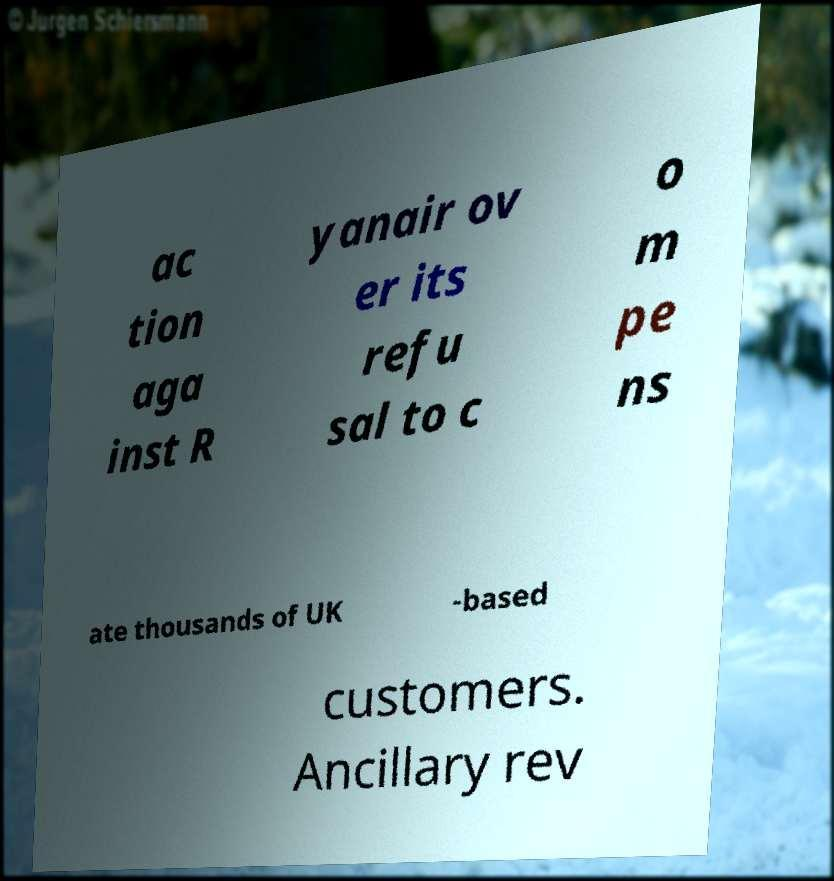Could you assist in decoding the text presented in this image and type it out clearly? ac tion aga inst R yanair ov er its refu sal to c o m pe ns ate thousands of UK -based customers. Ancillary rev 